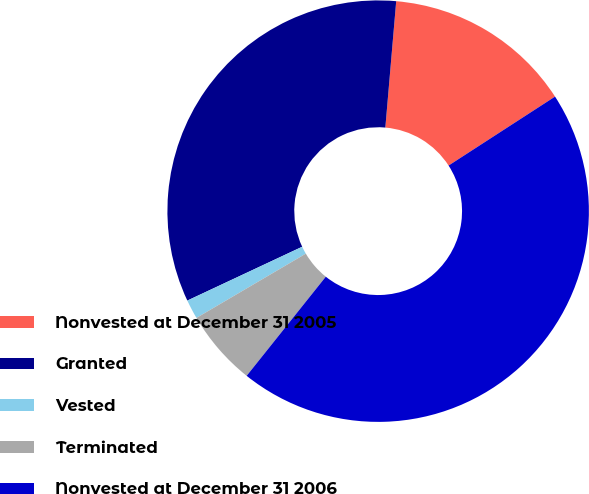<chart> <loc_0><loc_0><loc_500><loc_500><pie_chart><fcel>Nonvested at December 31 2005<fcel>Granted<fcel>Vested<fcel>Terminated<fcel>Nonvested at December 31 2006<nl><fcel>14.49%<fcel>33.34%<fcel>1.48%<fcel>5.82%<fcel>44.87%<nl></chart> 